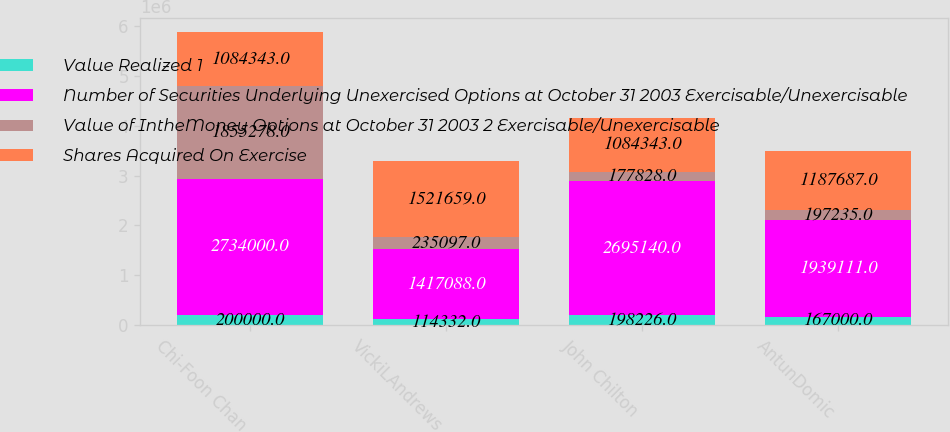Convert chart to OTSL. <chart><loc_0><loc_0><loc_500><loc_500><stacked_bar_chart><ecel><fcel>Chi-Foon Chan<fcel>VickiLAndrews<fcel>John Chilton<fcel>AntunDomic<nl><fcel>Value Realized 1<fcel>200000<fcel>114332<fcel>198226<fcel>167000<nl><fcel>Number of Securities Underlying Unexercised Options at October 31 2003 Exercisable/Unexercisable<fcel>2.734e+06<fcel>1.41709e+06<fcel>2.69514e+06<fcel>1.93911e+06<nl><fcel>Value of IntheMoney Options at October 31 2003 2 Exercisable/Unexercisable<fcel>1.85528e+06<fcel>235097<fcel>177828<fcel>197235<nl><fcel>Shares Acquired On Exercise<fcel>1.08434e+06<fcel>1.52166e+06<fcel>1.08434e+06<fcel>1.18769e+06<nl></chart> 